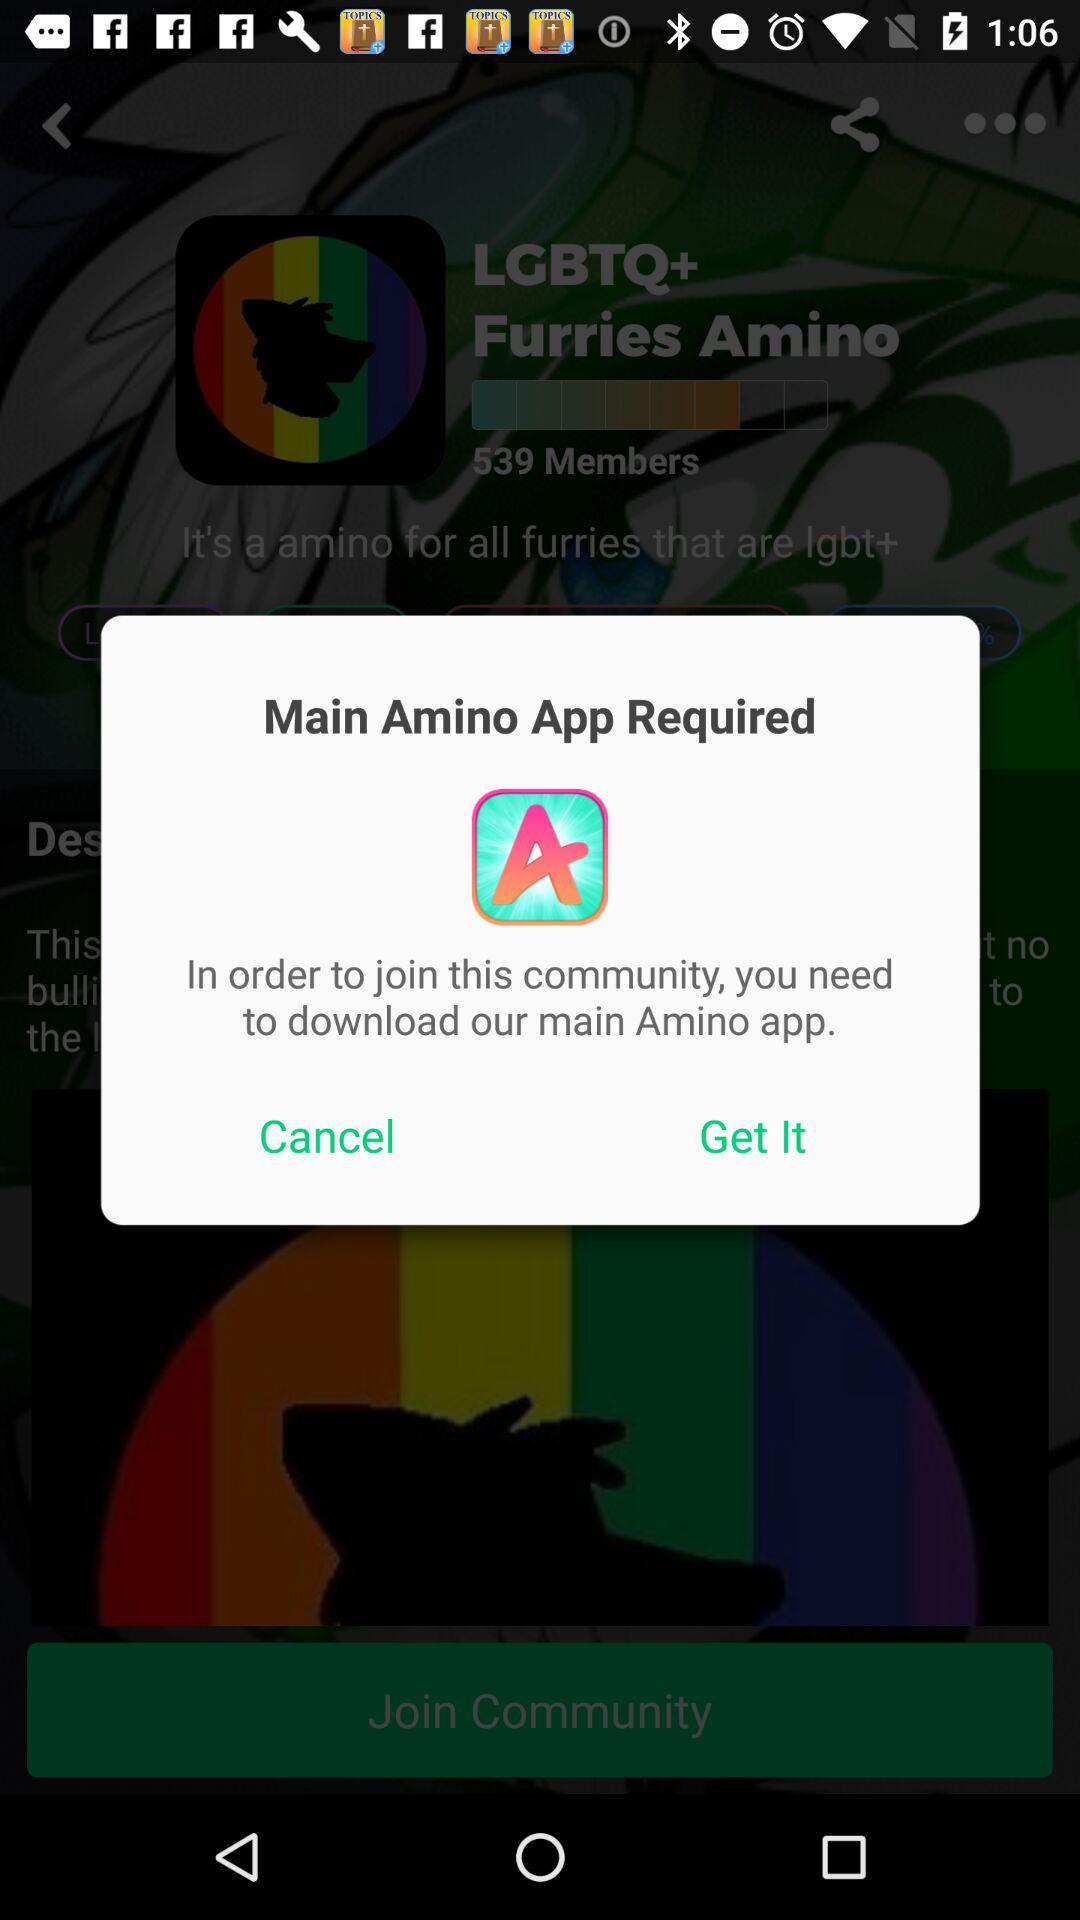Which app needs downloading? The app is "Main Amino App". 